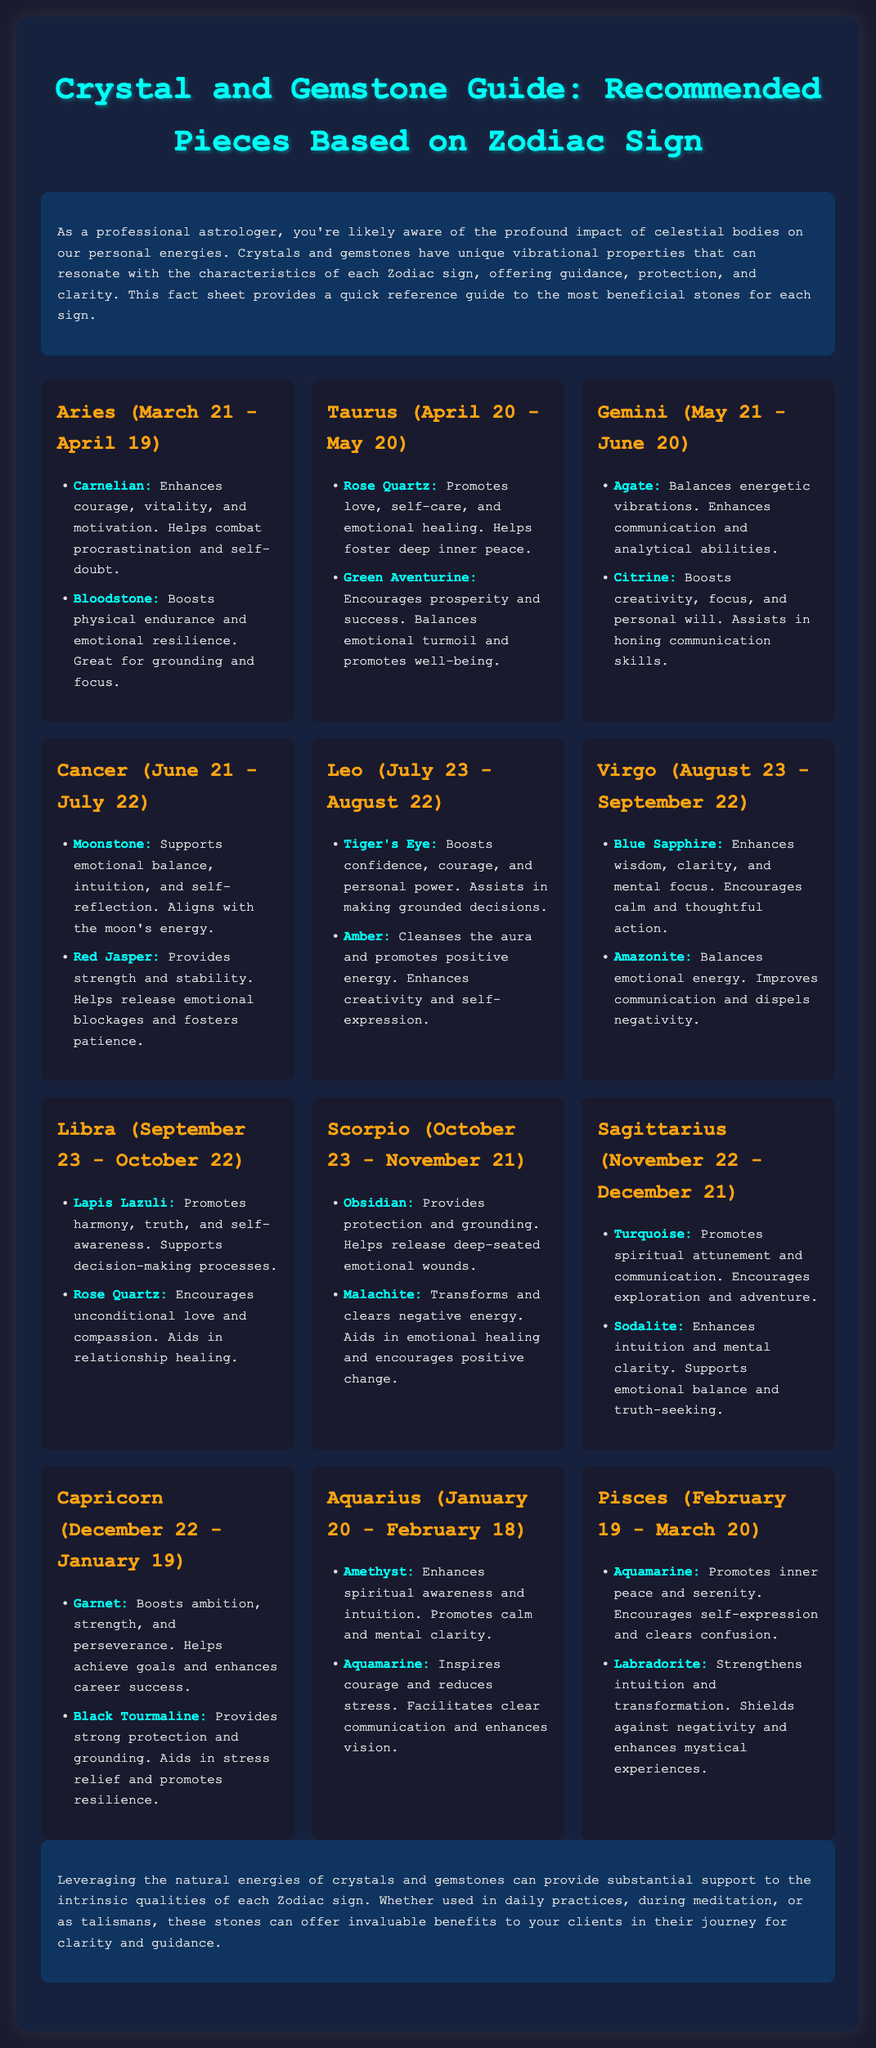What crystals are recommended for Aries? Aries is recommended to use Carnelian and Bloodstone for enhanced courage and endurance.
Answer: Carnelian, Bloodstone What does Rose Quartz promote for Taurus? Rose Quartz is noted for promoting love, self-care, and emotional healing for Taurus.
Answer: Love, self-care, emotional healing Which crystal is associated with emotional balance for Cancer? Moonstone is associated with emotional balance and intuition, benefiting Cancer.
Answer: Moonstone How many gemstones are recommended for Sagittarius? There are two gemstones listed for Sagittarius, which promotes spiritual attunement and communication.
Answer: Two What is a recommended crystal for Capricorn's career success? Garnet is noted as a crystal that boosts ambition and enhances career success for Capricorn.
Answer: Garnet Which zodiac sign is associated with Amethyst? Aquarius is the zodiac sign associated with Amethyst, enhancing spiritual awareness.
Answer: Aquarius What color is associated with the title of the document? The title color of the document is a bright teal, indicated by the styling in the header.
Answer: Bright teal What benefit does Turquoise offer for Sagittarius? Turquoise promotes spiritual attunement and communication, aiding Sagittarius.
Answer: Spiritual attunement, communication 